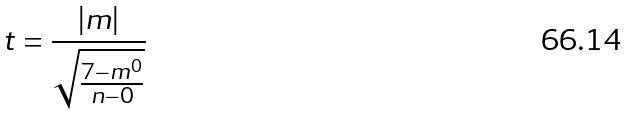Convert formula to latex. <formula><loc_0><loc_0><loc_500><loc_500>t = \frac { | m | } { \sqrt { \frac { 7 - m ^ { 0 } } { n - 0 } } }</formula> 